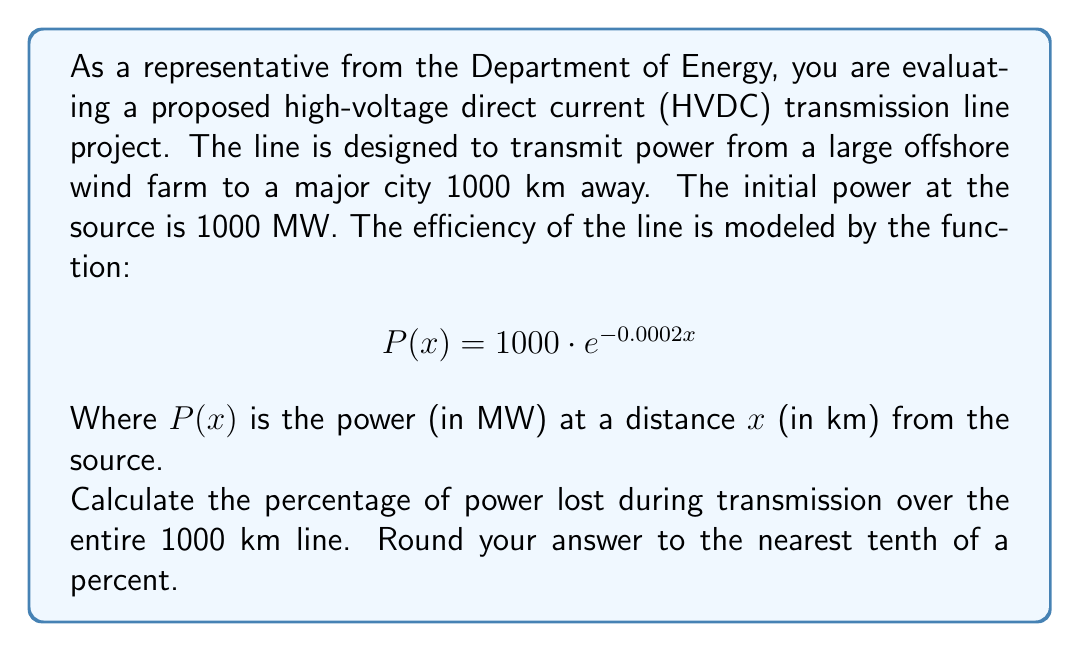Show me your answer to this math problem. To solve this problem, we need to follow these steps:

1) First, let's calculate the power at the end of the 1000 km line:
   $$P(1000) = 1000 \cdot e^{-0.0002 \cdot 1000}$$
   $$= 1000 \cdot e^{-0.2}$$
   $$\approx 818.73 \text{ MW}$$

2) Now, we can calculate the power lost:
   Power lost = Initial power - Final power
   $$= 1000 - 818.73 = 181.27 \text{ MW}$$

3) To express this as a percentage, we divide the power lost by the initial power and multiply by 100:
   Percentage lost = $\frac{\text{Power lost}}{\text{Initial power}} \cdot 100\%$
   $$= \frac{181.27}{1000} \cdot 100\%$$
   $$\approx 18.127\%$$

4) Rounding to the nearest tenth of a percent:
   18.1%

Therefore, approximately 18.1% of the power is lost during transmission.
Answer: 18.1% 